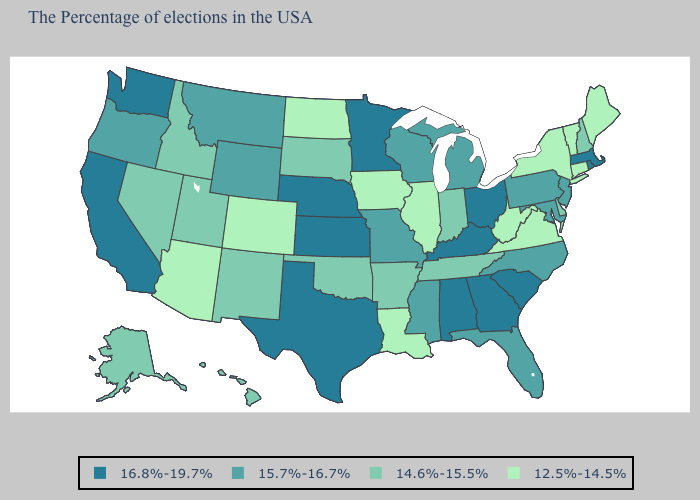Does Hawaii have the same value as New Hampshire?
Give a very brief answer. Yes. Name the states that have a value in the range 16.8%-19.7%?
Keep it brief. Massachusetts, Rhode Island, South Carolina, Ohio, Georgia, Kentucky, Alabama, Minnesota, Kansas, Nebraska, Texas, California, Washington. How many symbols are there in the legend?
Answer briefly. 4. What is the value of Arizona?
Give a very brief answer. 12.5%-14.5%. What is the lowest value in states that border Washington?
Quick response, please. 14.6%-15.5%. What is the lowest value in the Northeast?
Write a very short answer. 12.5%-14.5%. What is the value of New York?
Be succinct. 12.5%-14.5%. Name the states that have a value in the range 14.6%-15.5%?
Concise answer only. New Hampshire, Delaware, Indiana, Tennessee, Arkansas, Oklahoma, South Dakota, New Mexico, Utah, Idaho, Nevada, Alaska, Hawaii. Name the states that have a value in the range 15.7%-16.7%?
Give a very brief answer. New Jersey, Maryland, Pennsylvania, North Carolina, Florida, Michigan, Wisconsin, Mississippi, Missouri, Wyoming, Montana, Oregon. Does New Hampshire have the lowest value in the USA?
Write a very short answer. No. Does Ohio have the highest value in the MidWest?
Short answer required. Yes. What is the lowest value in the West?
Write a very short answer. 12.5%-14.5%. What is the value of Montana?
Write a very short answer. 15.7%-16.7%. Does Connecticut have the lowest value in the USA?
Answer briefly. Yes. How many symbols are there in the legend?
Be succinct. 4. 